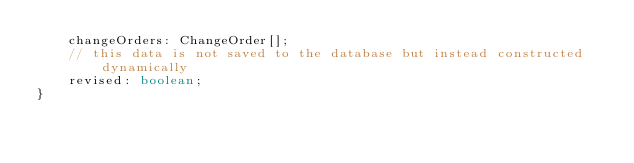Convert code to text. <code><loc_0><loc_0><loc_500><loc_500><_TypeScript_>	changeOrders: ChangeOrder[];
	// this data is not saved to the database but instead constructed dynamically
	revised: boolean;
}</code> 